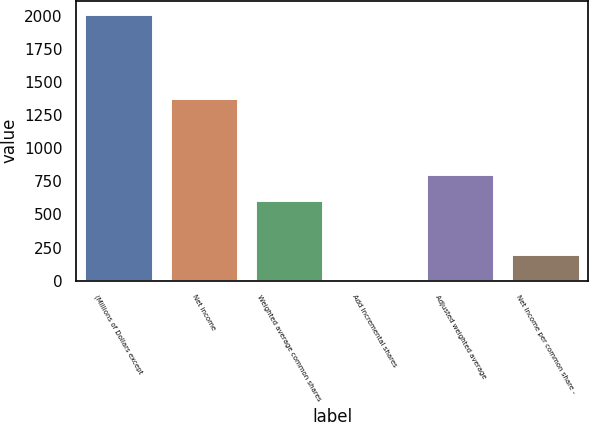Convert chart. <chart><loc_0><loc_0><loc_500><loc_500><bar_chart><fcel>(Millions of Dollars except<fcel>Net income<fcel>Weighted average common shares<fcel>Add Incremental shares<fcel>Adjusted weighted average<fcel>Net Income per common share -<nl><fcel>2018<fcel>1382<fcel>606.24<fcel>1.2<fcel>807.92<fcel>202.88<nl></chart> 